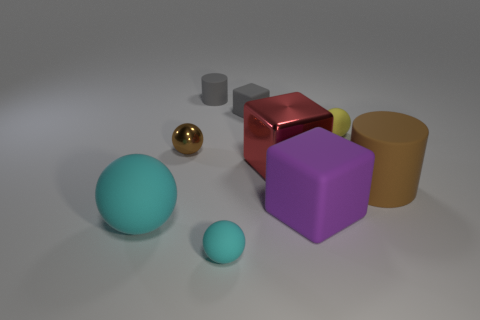Subtract all large matte cubes. How many cubes are left? 2 Subtract all cubes. How many objects are left? 6 Subtract all purple blocks. How many blocks are left? 2 Subtract 1 blocks. How many blocks are left? 2 Subtract all blue cylinders. How many cyan spheres are left? 2 Add 7 tiny gray matte blocks. How many tiny gray matte blocks are left? 8 Add 3 big green rubber cylinders. How many big green rubber cylinders exist? 3 Subtract 0 gray spheres. How many objects are left? 9 Subtract all gray balls. Subtract all red cylinders. How many balls are left? 4 Subtract all brown rubber objects. Subtract all red matte balls. How many objects are left? 8 